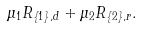<formula> <loc_0><loc_0><loc_500><loc_500>\mu _ { 1 } R _ { \left \{ 1 \right \} , d } + \mu _ { 2 } R _ { \left \{ 2 \right \} , r } .</formula> 